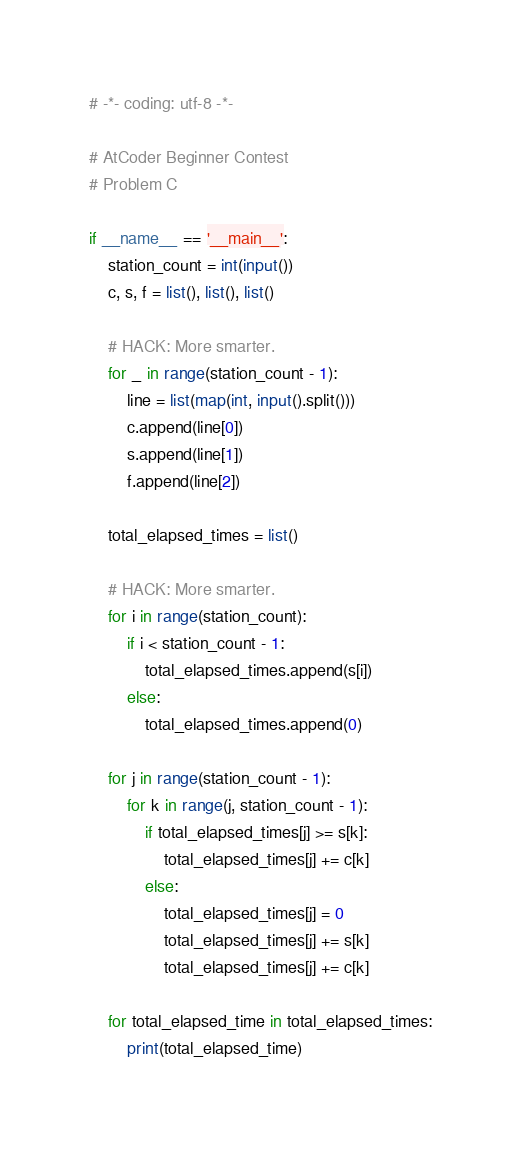Convert code to text. <code><loc_0><loc_0><loc_500><loc_500><_Python_># -*- coding: utf-8 -*-

# AtCoder Beginner Contest
# Problem C

if __name__ == '__main__':
    station_count = int(input())
    c, s, f = list(), list(), list()

    # HACK: More smarter.
    for _ in range(station_count - 1):
        line = list(map(int, input().split()))
        c.append(line[0])
        s.append(line[1])
        f.append(line[2])

    total_elapsed_times = list()

    # HACK: More smarter.
    for i in range(station_count):
        if i < station_count - 1:
            total_elapsed_times.append(s[i])
        else:
            total_elapsed_times.append(0)

    for j in range(station_count - 1):
        for k in range(j, station_count - 1):
            if total_elapsed_times[j] >= s[k]:
                total_elapsed_times[j] += c[k]
            else:
                total_elapsed_times[j] = 0
                total_elapsed_times[j] += s[k]
                total_elapsed_times[j] += c[k]

    for total_elapsed_time in total_elapsed_times:
        print(total_elapsed_time)
</code> 